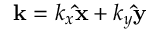<formula> <loc_0><loc_0><loc_500><loc_500>k = k _ { x } \hat { x } + k _ { y } \hat { y }</formula> 